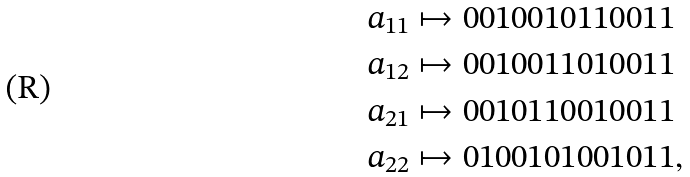Convert formula to latex. <formula><loc_0><loc_0><loc_500><loc_500>a _ { 1 1 } & \mapsto 0 0 1 0 0 1 0 1 1 0 0 1 1 \\ a _ { 1 2 } & \mapsto 0 0 1 0 0 1 1 0 1 0 0 1 1 \\ a _ { 2 1 } & \mapsto 0 0 1 0 1 1 0 0 1 0 0 1 1 \\ a _ { 2 2 } & \mapsto 0 1 0 0 1 0 1 0 0 1 0 1 1 ,</formula> 